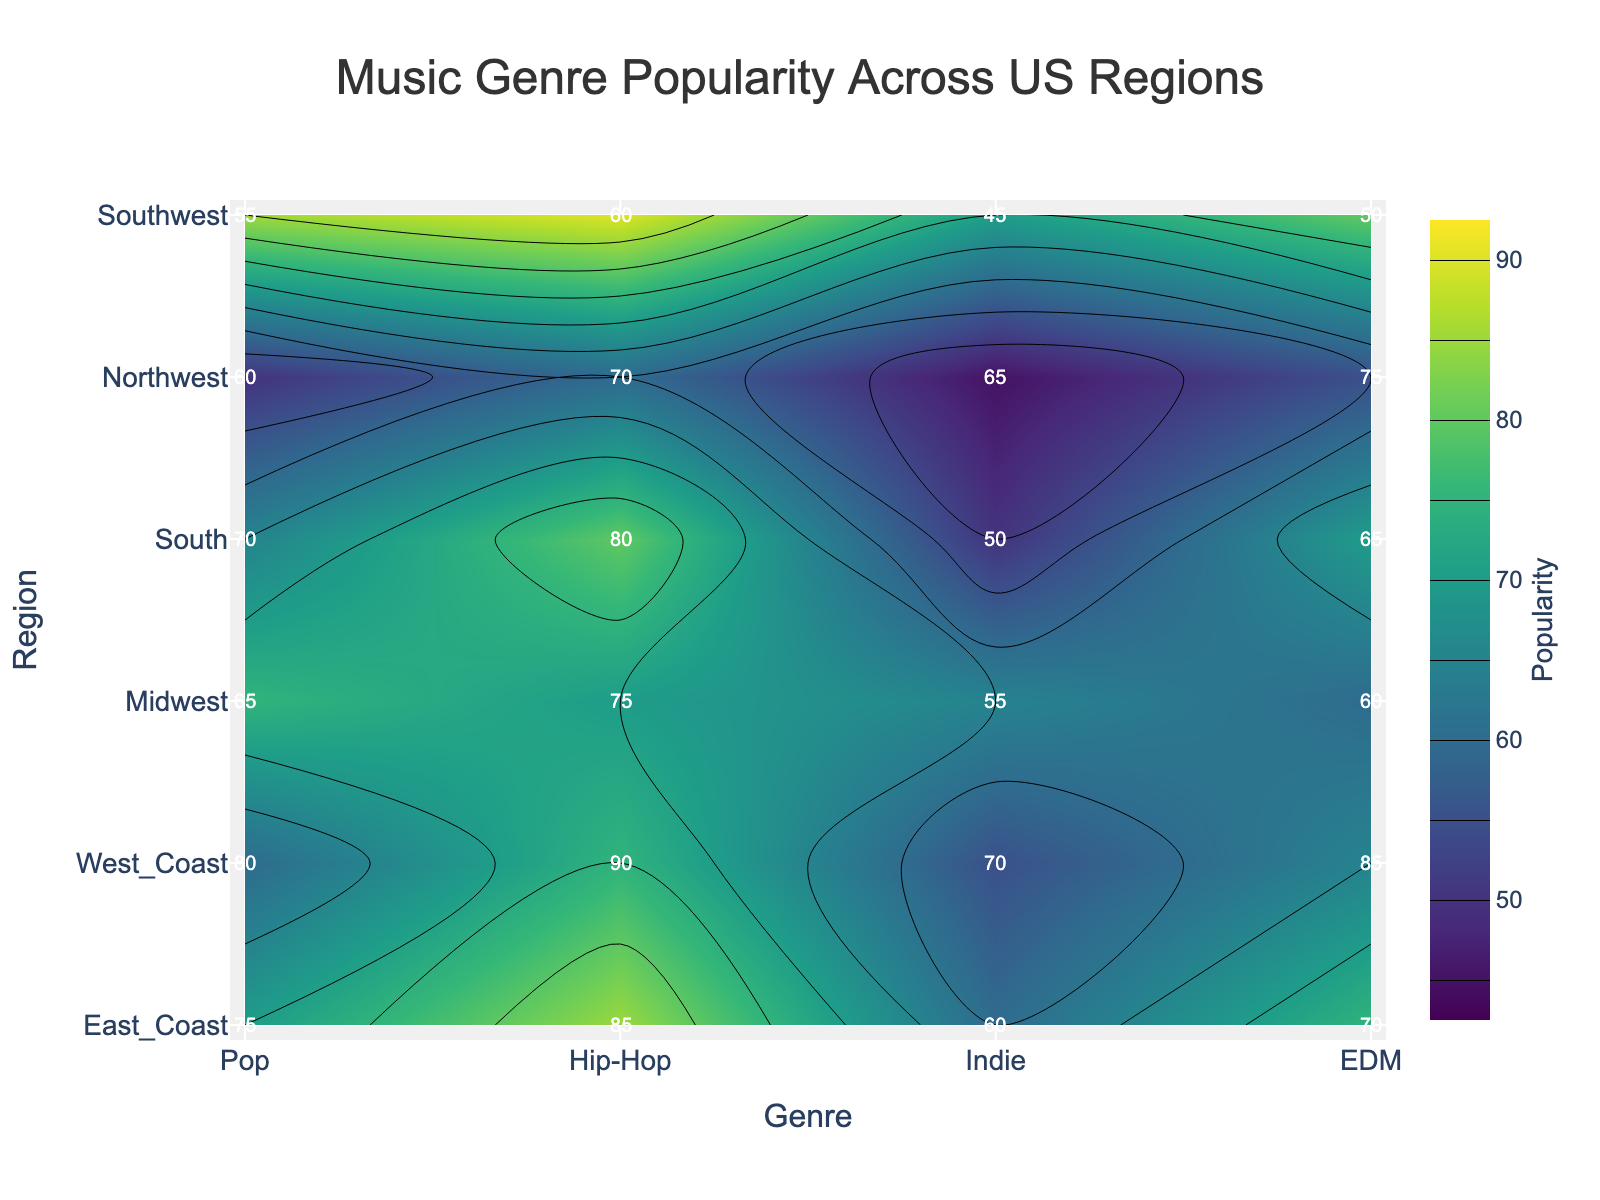What is the title of the figure? The title is usually located at the top of the figure and contains the main topic or the theme of the figure.
Answer: Music Genre Popularity Across US Regions Which region has the highest popularity score for Pop music? Locate the 'Pop' genre on the x-axis, and then find the highest value along this column.
Answer: West_Coast What is the popularity score for EDM in the Northwest region? Find 'EDM' on the x-axis and 'Northwest' on the y-axis, then look at the intersection point to get the value.
Answer: 75 Which region shows the lowest popularity for Indie music? Locate 'Indie' on the x-axis, and find the lowest value along this column.
Answer: Southwest Compare the popularity of Hip-Hop music between the East Coast and Midwest regions. Which one is higher and by how much? Find the values of 'Hip-Hop' for 'East Coast' and 'Midwest' on the respective row and column intersections, then subtract the lower value from the higher one. East Coast has 85, Midwest has 75, so 85 - 75 = 10.
Answer: East_Coast, 10 What's the average popularity score of Pop music across all regions? Add all the Pop scores and divide by the number of regions: (75 + 80 + 65 + 70 + 60 + 55)/6 = 67.5
Answer: 67.5 Which genre has the most consistent popularity across all regions? Look for the genre with the smallest range (difference between the highest and lowest values). Hip-Hop ranges from 60 to 90, Indie ranges from 45 to 70, EDM ranges from 50 to 85, Pop ranges from 55 to 80. The smallest range is for Pop.
Answer: Pop In which region is the difference between the popularity of Hip-Hop and Indie music the greatest? Calculate the difference between the Hip-Hop and Indie values for each region and find the maximum difference. West_Coast: 90-70 = 20, East_Coast: 85-60 = 25, South: 80-50 = 30, Midwest: 75-55 = 20, Northwest: 70-65 = 5, Southwest: 60-45 = 15. The greatest difference is in the South with 30.
Answer: South What is the median popularity score of EDM music across all regions? Arrange EDM scores in ascending order (50, 60, 65, 70, 75, 85) and find the median: The middle values are 65 and 70, so (65 + 70)/2 = 67.5.
Answer: 67.5 Which genre has the highest maximum popularity score in any region? Compare the maximum scores for each genre: Hip-Hop (90), Pop (80), Indie (70), EDM (85). Hip-Hop has the highest maximum popularity score.
Answer: Hip-Hop 